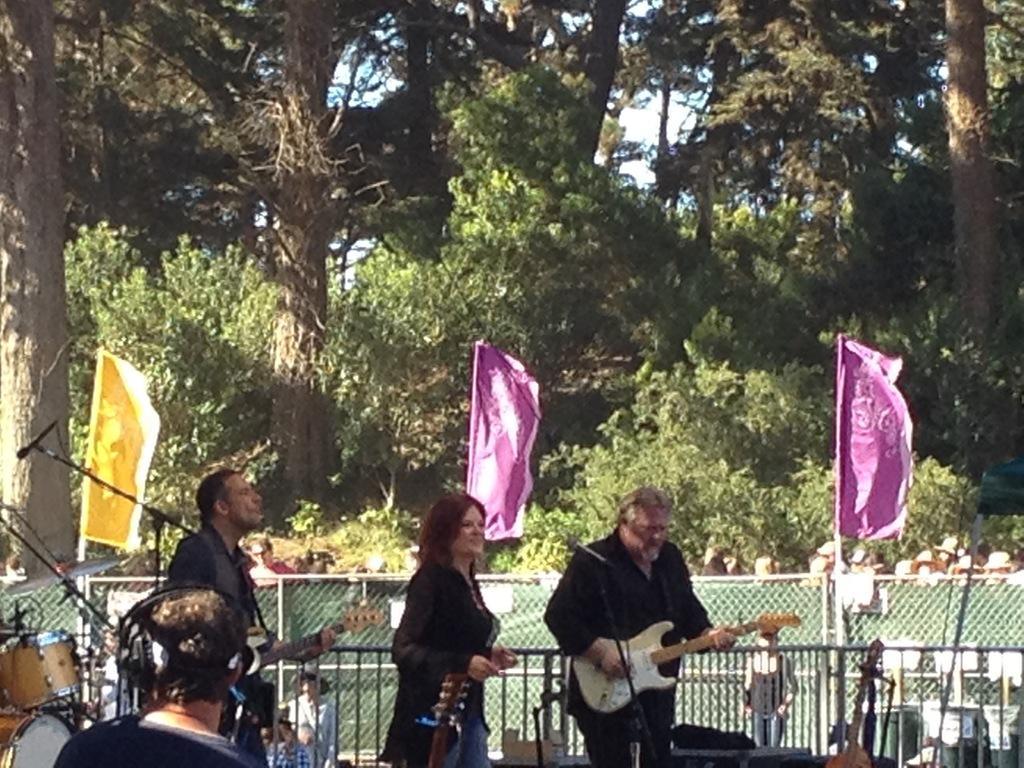Could you give a brief overview of what you see in this image? In this image, There are three persons standing and wearing clothes. These two persons are holding and playing a guitar. There are three flags at the center of this image. There is a fencing behind this person. There is a mic behind this person. There is a mic in front of this mic. This person is wearing headset on his head. There are some musical instruments behind these persons. There are some trees behind these persons. 